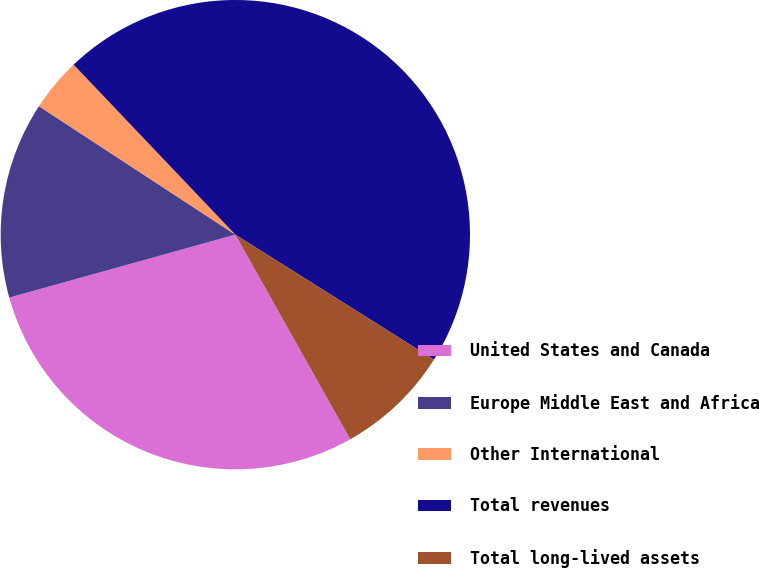<chart> <loc_0><loc_0><loc_500><loc_500><pie_chart><fcel>United States and Canada<fcel>Europe Middle East and Africa<fcel>Other International<fcel>Total revenues<fcel>Total long-lived assets<nl><fcel>28.82%<fcel>13.54%<fcel>3.68%<fcel>46.04%<fcel>7.92%<nl></chart> 